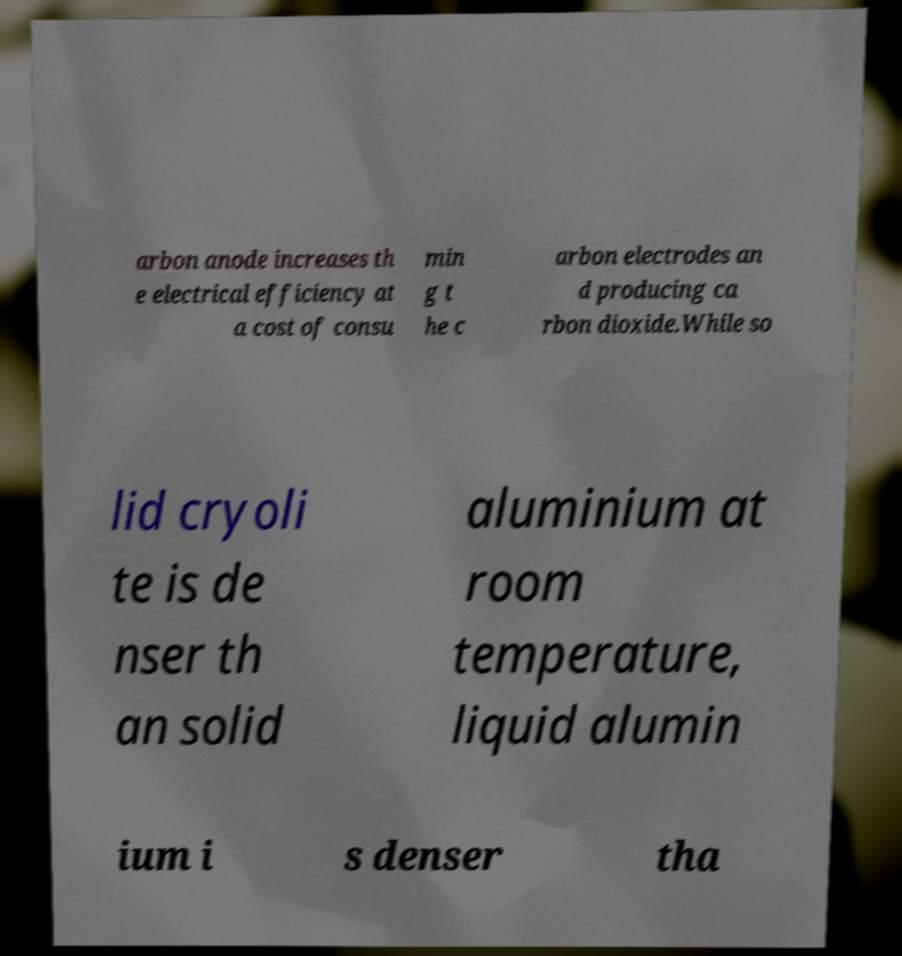Can you read and provide the text displayed in the image?This photo seems to have some interesting text. Can you extract and type it out for me? arbon anode increases th e electrical efficiency at a cost of consu min g t he c arbon electrodes an d producing ca rbon dioxide.While so lid cryoli te is de nser th an solid aluminium at room temperature, liquid alumin ium i s denser tha 